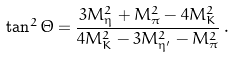<formula> <loc_0><loc_0><loc_500><loc_500>\tan ^ { 2 } \Theta = \frac { 3 M ^ { 2 } _ { \eta } + M _ { \pi } ^ { 2 } - 4 M _ { K } ^ { 2 } } { 4 M _ { K } ^ { 2 } - 3 M ^ { 2 } _ { \eta ^ { \prime } } - M _ { \pi } ^ { 2 } } \, .</formula> 